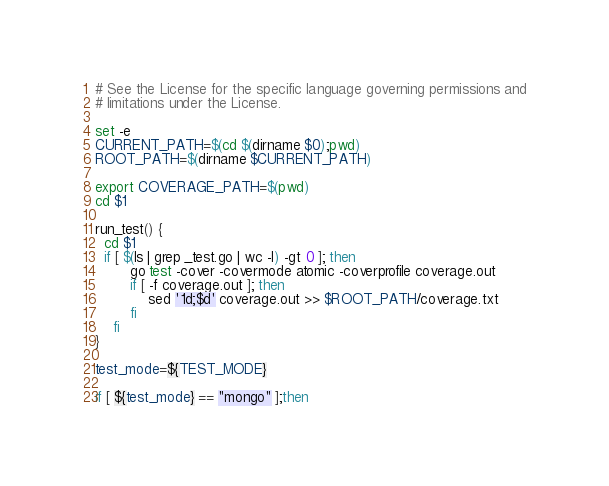<code> <loc_0><loc_0><loc_500><loc_500><_Bash_># See the License for the specific language governing permissions and
# limitations under the License.

set -e
CURRENT_PATH=$(cd $(dirname $0);pwd)
ROOT_PATH=$(dirname $CURRENT_PATH)

export COVERAGE_PATH=$(pwd)
cd $1

run_test() {
  cd $1
  if [ $(ls | grep _test.go | wc -l) -gt 0 ]; then
        go test -cover -covermode atomic -coverprofile coverage.out
        if [ -f coverage.out ]; then
            sed '1d;$d' coverage.out >> $ROOT_PATH/coverage.txt
        fi
    fi
}

test_mode=${TEST_MODE}

if [ ${test_mode} == "mongo" ];then</code> 